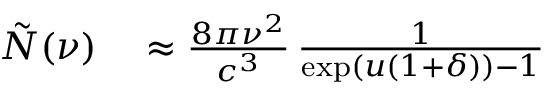<formula> <loc_0><loc_0><loc_500><loc_500>\begin{array} { r l } { \tilde { N } ( \nu ) } & \approx \frac { 8 \pi \nu ^ { 2 } } { c ^ { 3 } } \, \frac { 1 } { \exp ( u ( 1 + \delta ) ) - 1 } } \end{array}</formula> 